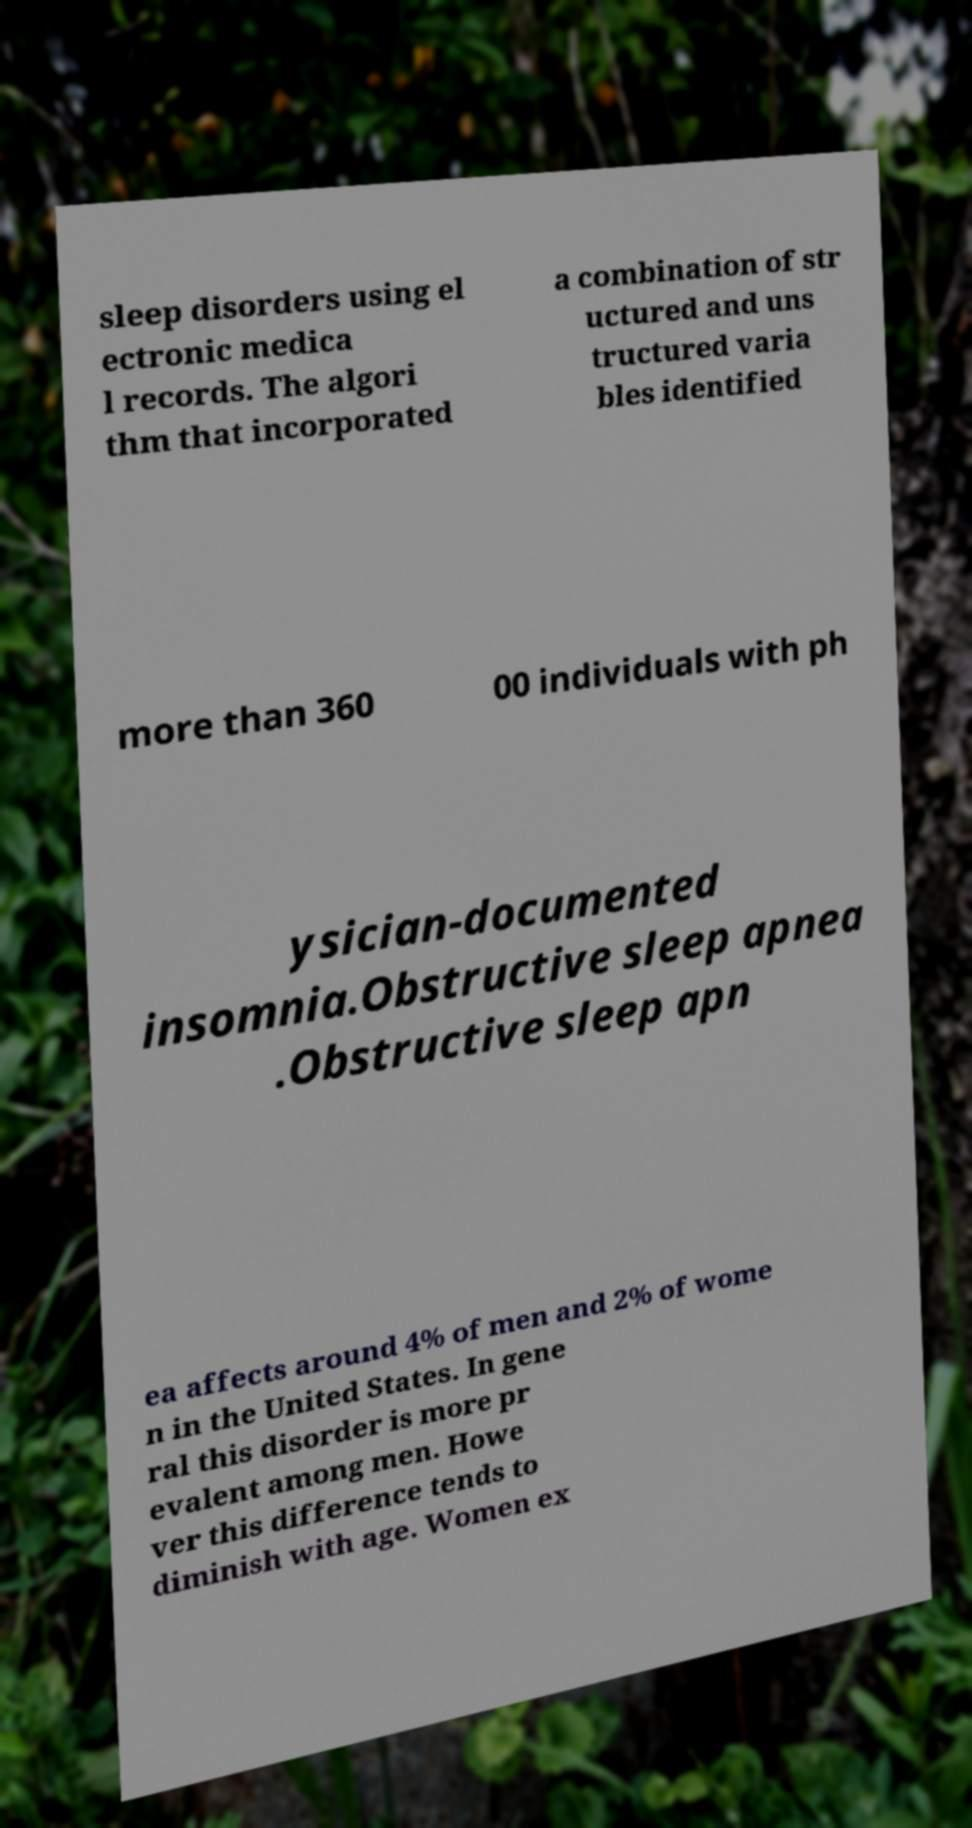For documentation purposes, I need the text within this image transcribed. Could you provide that? sleep disorders using el ectronic medica l records. The algori thm that incorporated a combination of str uctured and uns tructured varia bles identified more than 360 00 individuals with ph ysician-documented insomnia.Obstructive sleep apnea .Obstructive sleep apn ea affects around 4% of men and 2% of wome n in the United States. In gene ral this disorder is more pr evalent among men. Howe ver this difference tends to diminish with age. Women ex 